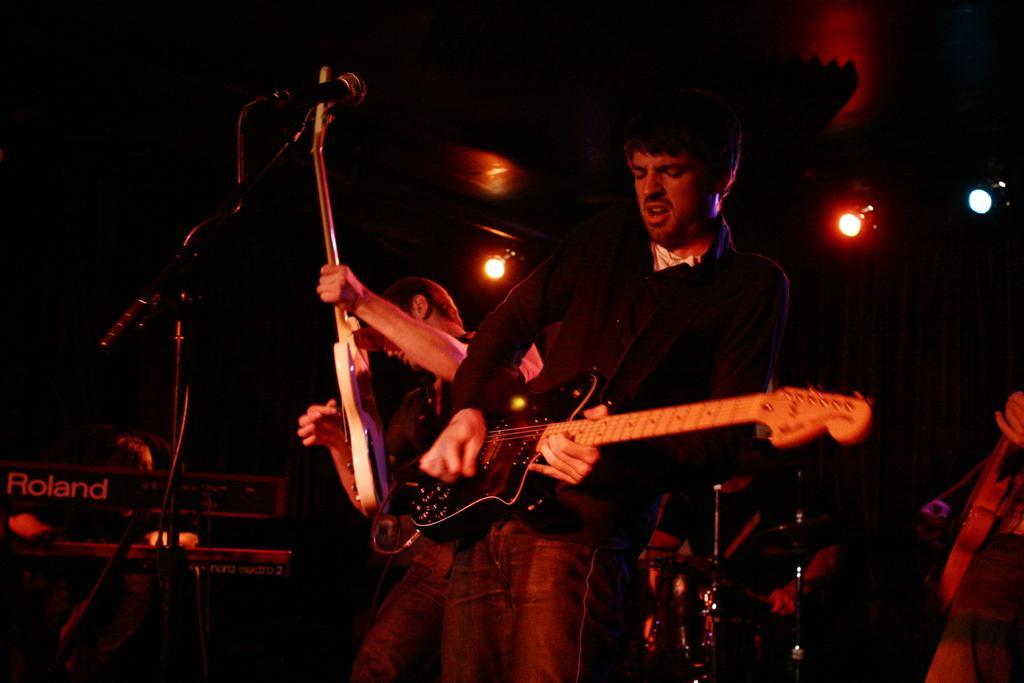How would you summarize this image in a sentence or two? The image looks like it is clicked in a concert. There are three men standing and performing some music. Each of them are playing guitars. In the middle the man is wearing black shirt and playing guitar and also singing. To the left there is a piano. And in the front there is a mic along with mic stand. 